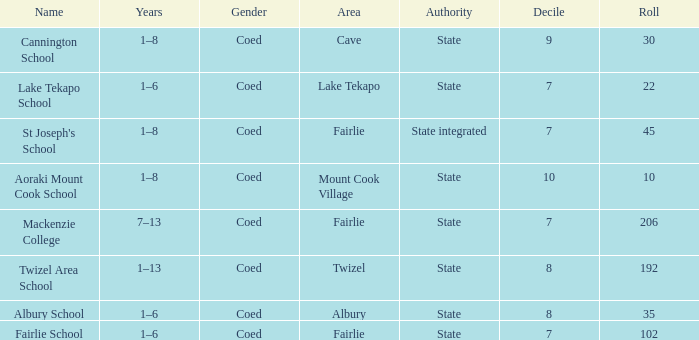What is the overall decile for a state authority, fairlie area, and roll greater than 206? 1.0. Parse the table in full. {'header': ['Name', 'Years', 'Gender', 'Area', 'Authority', 'Decile', 'Roll'], 'rows': [['Cannington School', '1–8', 'Coed', 'Cave', 'State', '9', '30'], ['Lake Tekapo School', '1–6', 'Coed', 'Lake Tekapo', 'State', '7', '22'], ["St Joseph's School", '1–8', 'Coed', 'Fairlie', 'State integrated', '7', '45'], ['Aoraki Mount Cook School', '1–8', 'Coed', 'Mount Cook Village', 'State', '10', '10'], ['Mackenzie College', '7–13', 'Coed', 'Fairlie', 'State', '7', '206'], ['Twizel Area School', '1–13', 'Coed', 'Twizel', 'State', '8', '192'], ['Albury School', '1–6', 'Coed', 'Albury', 'State', '8', '35'], ['Fairlie School', '1–6', 'Coed', 'Fairlie', 'State', '7', '102']]} 